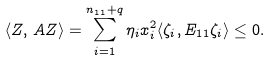Convert formula to latex. <formula><loc_0><loc_0><loc_500><loc_500>\langle Z , \, A Z \rangle = \sum _ { i = 1 } ^ { n _ { 1 1 } + q } \eta _ { i } x _ { i } ^ { 2 } \langle \zeta _ { i } , E _ { 1 1 } \zeta _ { i } \rangle \leq 0 .</formula> 